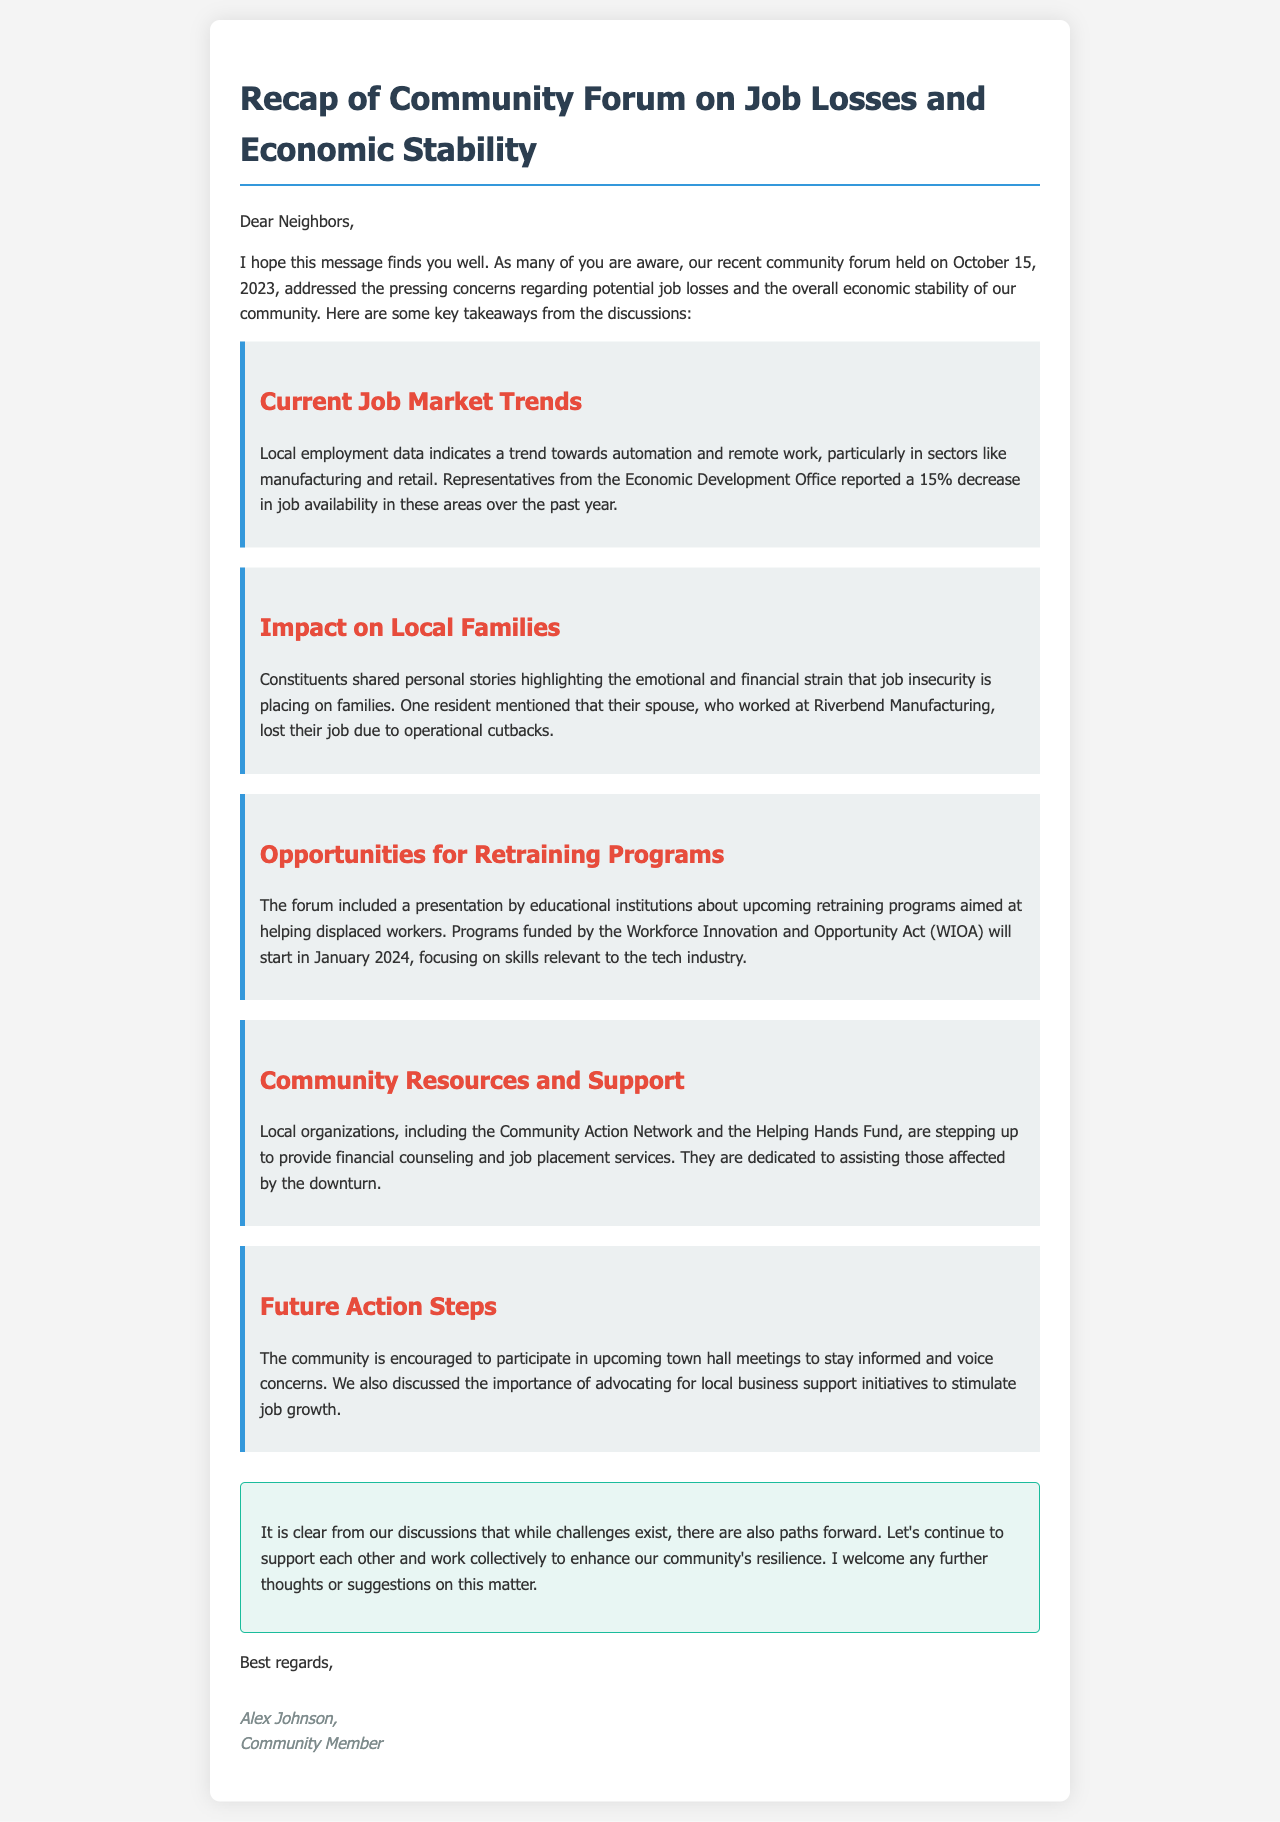What was the date of the community forum? The document states that the community forum was held on October 15, 2023.
Answer: October 15, 2023 What percentage decrease in job availability was reported? The Economic Development Office reported a 15% decrease in job availability over the past year.
Answer: 15% Which sector has seen trends towards automation and remote work? The document mentions manufacturing and retail as sectors experiencing these trends.
Answer: Manufacturing and retail When will the retraining programs start? The document states that the retraining programs will start in January 2024.
Answer: January 2024 What type of support do local organizations provide? The document mentions financial counseling and job placement services as support offered by local organizations.
Answer: Financial counseling and job placement services What is the name of the act funding the retraining programs? The document refers to the Workforce Innovation and Opportunity Act (WIOA) as the act funding the retraining programs.
Answer: Workforce Innovation and Opportunity Act (WIOA) What is one effect of job insecurity mentioned by a resident? One resident mentioned the emotional and financial strain that job insecurity places on families.
Answer: Emotional and financial strain What are residents encouraged to participate in for more information? The document encourages residents to participate in upcoming town hall meetings.
Answer: Town hall meetings Who is the author of the email? The document identifies Alex Johnson as the author of the email.
Answer: Alex Johnson 